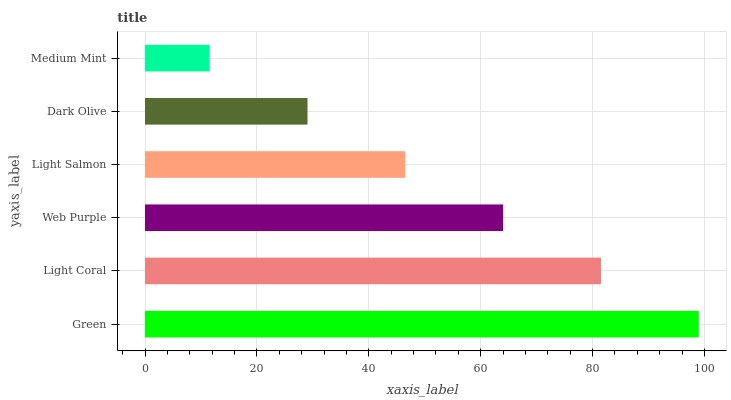Is Medium Mint the minimum?
Answer yes or no. Yes. Is Green the maximum?
Answer yes or no. Yes. Is Light Coral the minimum?
Answer yes or no. No. Is Light Coral the maximum?
Answer yes or no. No. Is Green greater than Light Coral?
Answer yes or no. Yes. Is Light Coral less than Green?
Answer yes or no. Yes. Is Light Coral greater than Green?
Answer yes or no. No. Is Green less than Light Coral?
Answer yes or no. No. Is Web Purple the high median?
Answer yes or no. Yes. Is Light Salmon the low median?
Answer yes or no. Yes. Is Green the high median?
Answer yes or no. No. Is Web Purple the low median?
Answer yes or no. No. 